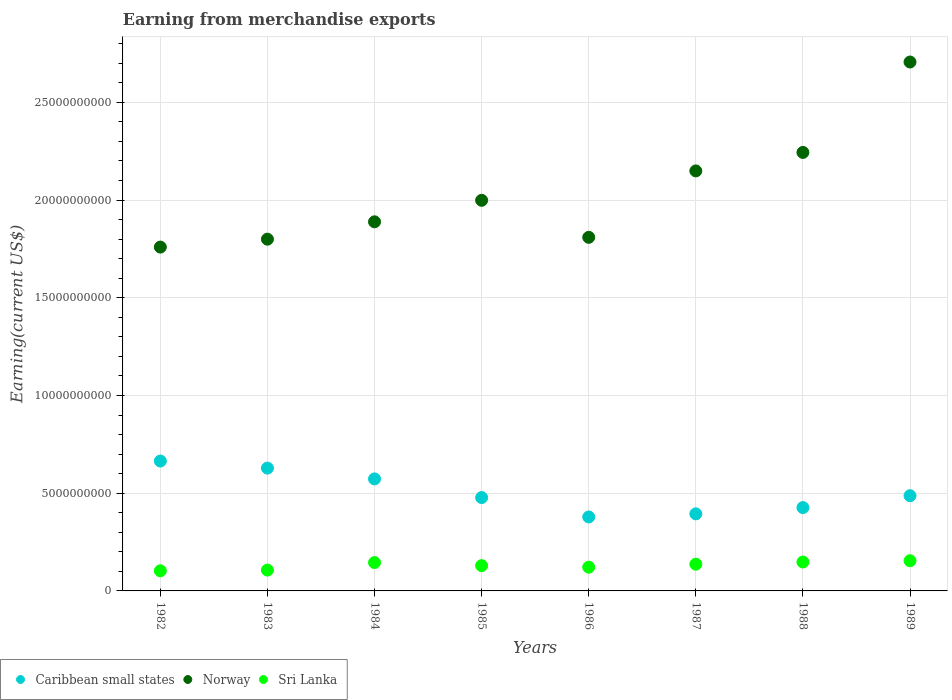Is the number of dotlines equal to the number of legend labels?
Offer a very short reply. Yes. What is the amount earned from merchandise exports in Norway in 1989?
Your response must be concise. 2.71e+1. Across all years, what is the maximum amount earned from merchandise exports in Norway?
Ensure brevity in your answer.  2.71e+1. Across all years, what is the minimum amount earned from merchandise exports in Sri Lanka?
Give a very brief answer. 1.03e+09. In which year was the amount earned from merchandise exports in Norway minimum?
Your answer should be very brief. 1982. What is the total amount earned from merchandise exports in Norway in the graph?
Give a very brief answer. 1.64e+11. What is the difference between the amount earned from merchandise exports in Sri Lanka in 1986 and that in 1989?
Keep it short and to the point. -3.30e+08. What is the difference between the amount earned from merchandise exports in Sri Lanka in 1984 and the amount earned from merchandise exports in Norway in 1982?
Provide a short and direct response. -1.61e+1. What is the average amount earned from merchandise exports in Norway per year?
Keep it short and to the point. 2.04e+1. In the year 1987, what is the difference between the amount earned from merchandise exports in Sri Lanka and amount earned from merchandise exports in Caribbean small states?
Your answer should be very brief. -2.58e+09. In how many years, is the amount earned from merchandise exports in Norway greater than 8000000000 US$?
Your response must be concise. 8. What is the ratio of the amount earned from merchandise exports in Caribbean small states in 1985 to that in 1987?
Offer a very short reply. 1.21. Is the difference between the amount earned from merchandise exports in Sri Lanka in 1986 and 1988 greater than the difference between the amount earned from merchandise exports in Caribbean small states in 1986 and 1988?
Offer a terse response. Yes. What is the difference between the highest and the second highest amount earned from merchandise exports in Norway?
Offer a terse response. 4.63e+09. What is the difference between the highest and the lowest amount earned from merchandise exports in Caribbean small states?
Offer a terse response. 2.86e+09. In how many years, is the amount earned from merchandise exports in Caribbean small states greater than the average amount earned from merchandise exports in Caribbean small states taken over all years?
Keep it short and to the point. 3. Does the amount earned from merchandise exports in Sri Lanka monotonically increase over the years?
Provide a succinct answer. No. Is the amount earned from merchandise exports in Sri Lanka strictly greater than the amount earned from merchandise exports in Norway over the years?
Keep it short and to the point. No. Is the amount earned from merchandise exports in Sri Lanka strictly less than the amount earned from merchandise exports in Norway over the years?
Your response must be concise. Yes. How many dotlines are there?
Give a very brief answer. 3. How many years are there in the graph?
Your answer should be compact. 8. Are the values on the major ticks of Y-axis written in scientific E-notation?
Ensure brevity in your answer.  No. Does the graph contain any zero values?
Offer a very short reply. No. Does the graph contain grids?
Provide a short and direct response. Yes. How are the legend labels stacked?
Make the answer very short. Horizontal. What is the title of the graph?
Offer a terse response. Earning from merchandise exports. Does "Indonesia" appear as one of the legend labels in the graph?
Your answer should be compact. No. What is the label or title of the Y-axis?
Offer a terse response. Earning(current US$). What is the Earning(current US$) of Caribbean small states in 1982?
Offer a terse response. 6.65e+09. What is the Earning(current US$) in Norway in 1982?
Your answer should be very brief. 1.76e+1. What is the Earning(current US$) in Sri Lanka in 1982?
Offer a terse response. 1.03e+09. What is the Earning(current US$) of Caribbean small states in 1983?
Offer a terse response. 6.28e+09. What is the Earning(current US$) in Norway in 1983?
Provide a succinct answer. 1.80e+1. What is the Earning(current US$) in Sri Lanka in 1983?
Offer a terse response. 1.07e+09. What is the Earning(current US$) of Caribbean small states in 1984?
Give a very brief answer. 5.73e+09. What is the Earning(current US$) in Norway in 1984?
Your answer should be very brief. 1.89e+1. What is the Earning(current US$) of Sri Lanka in 1984?
Provide a succinct answer. 1.45e+09. What is the Earning(current US$) in Caribbean small states in 1985?
Your response must be concise. 4.78e+09. What is the Earning(current US$) of Norway in 1985?
Offer a very short reply. 2.00e+1. What is the Earning(current US$) in Sri Lanka in 1985?
Keep it short and to the point. 1.29e+09. What is the Earning(current US$) in Caribbean small states in 1986?
Give a very brief answer. 3.78e+09. What is the Earning(current US$) of Norway in 1986?
Give a very brief answer. 1.81e+1. What is the Earning(current US$) in Sri Lanka in 1986?
Give a very brief answer. 1.22e+09. What is the Earning(current US$) of Caribbean small states in 1987?
Offer a very short reply. 3.94e+09. What is the Earning(current US$) in Norway in 1987?
Offer a very short reply. 2.15e+1. What is the Earning(current US$) of Sri Lanka in 1987?
Provide a succinct answer. 1.37e+09. What is the Earning(current US$) of Caribbean small states in 1988?
Provide a short and direct response. 4.26e+09. What is the Earning(current US$) of Norway in 1988?
Offer a very short reply. 2.24e+1. What is the Earning(current US$) in Sri Lanka in 1988?
Give a very brief answer. 1.48e+09. What is the Earning(current US$) of Caribbean small states in 1989?
Your response must be concise. 4.87e+09. What is the Earning(current US$) of Norway in 1989?
Offer a very short reply. 2.71e+1. What is the Earning(current US$) in Sri Lanka in 1989?
Your answer should be compact. 1.54e+09. Across all years, what is the maximum Earning(current US$) of Caribbean small states?
Give a very brief answer. 6.65e+09. Across all years, what is the maximum Earning(current US$) of Norway?
Provide a short and direct response. 2.71e+1. Across all years, what is the maximum Earning(current US$) in Sri Lanka?
Your response must be concise. 1.54e+09. Across all years, what is the minimum Earning(current US$) of Caribbean small states?
Provide a short and direct response. 3.78e+09. Across all years, what is the minimum Earning(current US$) in Norway?
Your answer should be compact. 1.76e+1. Across all years, what is the minimum Earning(current US$) of Sri Lanka?
Your answer should be very brief. 1.03e+09. What is the total Earning(current US$) of Caribbean small states in the graph?
Give a very brief answer. 4.03e+1. What is the total Earning(current US$) of Norway in the graph?
Give a very brief answer. 1.64e+11. What is the total Earning(current US$) of Sri Lanka in the graph?
Offer a very short reply. 1.04e+1. What is the difference between the Earning(current US$) in Caribbean small states in 1982 and that in 1983?
Your answer should be very brief. 3.62e+08. What is the difference between the Earning(current US$) of Norway in 1982 and that in 1983?
Offer a terse response. -4.04e+08. What is the difference between the Earning(current US$) in Sri Lanka in 1982 and that in 1983?
Your response must be concise. -3.60e+07. What is the difference between the Earning(current US$) in Caribbean small states in 1982 and that in 1984?
Offer a very short reply. 9.14e+08. What is the difference between the Earning(current US$) in Norway in 1982 and that in 1984?
Provide a short and direct response. -1.29e+09. What is the difference between the Earning(current US$) in Sri Lanka in 1982 and that in 1984?
Give a very brief answer. -4.21e+08. What is the difference between the Earning(current US$) of Caribbean small states in 1982 and that in 1985?
Your answer should be very brief. 1.87e+09. What is the difference between the Earning(current US$) of Norway in 1982 and that in 1985?
Make the answer very short. -2.39e+09. What is the difference between the Earning(current US$) in Sri Lanka in 1982 and that in 1985?
Make the answer very short. -2.63e+08. What is the difference between the Earning(current US$) of Caribbean small states in 1982 and that in 1986?
Provide a succinct answer. 2.86e+09. What is the difference between the Earning(current US$) of Norway in 1982 and that in 1986?
Your response must be concise. -4.99e+08. What is the difference between the Earning(current US$) in Sri Lanka in 1982 and that in 1986?
Keep it short and to the point. -1.85e+08. What is the difference between the Earning(current US$) of Caribbean small states in 1982 and that in 1987?
Offer a terse response. 2.70e+09. What is the difference between the Earning(current US$) of Norway in 1982 and that in 1987?
Your response must be concise. -3.90e+09. What is the difference between the Earning(current US$) of Sri Lanka in 1982 and that in 1987?
Your answer should be compact. -3.38e+08. What is the difference between the Earning(current US$) of Caribbean small states in 1982 and that in 1988?
Give a very brief answer. 2.38e+09. What is the difference between the Earning(current US$) of Norway in 1982 and that in 1988?
Provide a short and direct response. -4.84e+09. What is the difference between the Earning(current US$) in Sri Lanka in 1982 and that in 1988?
Provide a succinct answer. -4.49e+08. What is the difference between the Earning(current US$) in Caribbean small states in 1982 and that in 1989?
Ensure brevity in your answer.  1.77e+09. What is the difference between the Earning(current US$) of Norway in 1982 and that in 1989?
Make the answer very short. -9.47e+09. What is the difference between the Earning(current US$) of Sri Lanka in 1982 and that in 1989?
Keep it short and to the point. -5.15e+08. What is the difference between the Earning(current US$) in Caribbean small states in 1983 and that in 1984?
Make the answer very short. 5.52e+08. What is the difference between the Earning(current US$) in Norway in 1983 and that in 1984?
Provide a succinct answer. -8.89e+08. What is the difference between the Earning(current US$) of Sri Lanka in 1983 and that in 1984?
Your response must be concise. -3.85e+08. What is the difference between the Earning(current US$) of Caribbean small states in 1983 and that in 1985?
Offer a very short reply. 1.51e+09. What is the difference between the Earning(current US$) in Norway in 1983 and that in 1985?
Ensure brevity in your answer.  -1.99e+09. What is the difference between the Earning(current US$) in Sri Lanka in 1983 and that in 1985?
Keep it short and to the point. -2.27e+08. What is the difference between the Earning(current US$) of Caribbean small states in 1983 and that in 1986?
Your answer should be compact. 2.50e+09. What is the difference between the Earning(current US$) in Norway in 1983 and that in 1986?
Provide a succinct answer. -9.50e+07. What is the difference between the Earning(current US$) in Sri Lanka in 1983 and that in 1986?
Your answer should be compact. -1.49e+08. What is the difference between the Earning(current US$) of Caribbean small states in 1983 and that in 1987?
Provide a short and direct response. 2.34e+09. What is the difference between the Earning(current US$) in Norway in 1983 and that in 1987?
Keep it short and to the point. -3.49e+09. What is the difference between the Earning(current US$) of Sri Lanka in 1983 and that in 1987?
Provide a succinct answer. -3.02e+08. What is the difference between the Earning(current US$) of Caribbean small states in 1983 and that in 1988?
Your answer should be compact. 2.02e+09. What is the difference between the Earning(current US$) in Norway in 1983 and that in 1988?
Offer a terse response. -4.44e+09. What is the difference between the Earning(current US$) of Sri Lanka in 1983 and that in 1988?
Provide a short and direct response. -4.13e+08. What is the difference between the Earning(current US$) in Caribbean small states in 1983 and that in 1989?
Give a very brief answer. 1.41e+09. What is the difference between the Earning(current US$) in Norway in 1983 and that in 1989?
Your answer should be compact. -9.06e+09. What is the difference between the Earning(current US$) of Sri Lanka in 1983 and that in 1989?
Give a very brief answer. -4.79e+08. What is the difference between the Earning(current US$) of Caribbean small states in 1984 and that in 1985?
Provide a short and direct response. 9.55e+08. What is the difference between the Earning(current US$) of Norway in 1984 and that in 1985?
Give a very brief answer. -1.10e+09. What is the difference between the Earning(current US$) in Sri Lanka in 1984 and that in 1985?
Your answer should be compact. 1.58e+08. What is the difference between the Earning(current US$) in Caribbean small states in 1984 and that in 1986?
Your answer should be very brief. 1.95e+09. What is the difference between the Earning(current US$) of Norway in 1984 and that in 1986?
Ensure brevity in your answer.  7.94e+08. What is the difference between the Earning(current US$) in Sri Lanka in 1984 and that in 1986?
Ensure brevity in your answer.  2.36e+08. What is the difference between the Earning(current US$) of Caribbean small states in 1984 and that in 1987?
Provide a succinct answer. 1.79e+09. What is the difference between the Earning(current US$) in Norway in 1984 and that in 1987?
Your answer should be very brief. -2.60e+09. What is the difference between the Earning(current US$) of Sri Lanka in 1984 and that in 1987?
Keep it short and to the point. 8.30e+07. What is the difference between the Earning(current US$) of Caribbean small states in 1984 and that in 1988?
Your answer should be compact. 1.47e+09. What is the difference between the Earning(current US$) of Norway in 1984 and that in 1988?
Your answer should be very brief. -3.55e+09. What is the difference between the Earning(current US$) in Sri Lanka in 1984 and that in 1988?
Offer a very short reply. -2.80e+07. What is the difference between the Earning(current US$) in Caribbean small states in 1984 and that in 1989?
Give a very brief answer. 8.60e+08. What is the difference between the Earning(current US$) of Norway in 1984 and that in 1989?
Your answer should be very brief. -8.18e+09. What is the difference between the Earning(current US$) in Sri Lanka in 1984 and that in 1989?
Make the answer very short. -9.40e+07. What is the difference between the Earning(current US$) in Caribbean small states in 1985 and that in 1986?
Your answer should be compact. 9.92e+08. What is the difference between the Earning(current US$) of Norway in 1985 and that in 1986?
Your response must be concise. 1.89e+09. What is the difference between the Earning(current US$) in Sri Lanka in 1985 and that in 1986?
Make the answer very short. 7.80e+07. What is the difference between the Earning(current US$) in Caribbean small states in 1985 and that in 1987?
Give a very brief answer. 8.34e+08. What is the difference between the Earning(current US$) of Norway in 1985 and that in 1987?
Offer a very short reply. -1.50e+09. What is the difference between the Earning(current US$) in Sri Lanka in 1985 and that in 1987?
Your answer should be compact. -7.50e+07. What is the difference between the Earning(current US$) in Caribbean small states in 1985 and that in 1988?
Make the answer very short. 5.13e+08. What is the difference between the Earning(current US$) in Norway in 1985 and that in 1988?
Offer a terse response. -2.45e+09. What is the difference between the Earning(current US$) in Sri Lanka in 1985 and that in 1988?
Offer a very short reply. -1.86e+08. What is the difference between the Earning(current US$) in Caribbean small states in 1985 and that in 1989?
Ensure brevity in your answer.  -9.50e+07. What is the difference between the Earning(current US$) in Norway in 1985 and that in 1989?
Keep it short and to the point. -7.08e+09. What is the difference between the Earning(current US$) of Sri Lanka in 1985 and that in 1989?
Keep it short and to the point. -2.52e+08. What is the difference between the Earning(current US$) in Caribbean small states in 1986 and that in 1987?
Offer a very short reply. -1.58e+08. What is the difference between the Earning(current US$) in Norway in 1986 and that in 1987?
Keep it short and to the point. -3.40e+09. What is the difference between the Earning(current US$) in Sri Lanka in 1986 and that in 1987?
Give a very brief answer. -1.53e+08. What is the difference between the Earning(current US$) of Caribbean small states in 1986 and that in 1988?
Give a very brief answer. -4.79e+08. What is the difference between the Earning(current US$) in Norway in 1986 and that in 1988?
Give a very brief answer. -4.34e+09. What is the difference between the Earning(current US$) of Sri Lanka in 1986 and that in 1988?
Make the answer very short. -2.64e+08. What is the difference between the Earning(current US$) of Caribbean small states in 1986 and that in 1989?
Ensure brevity in your answer.  -1.09e+09. What is the difference between the Earning(current US$) of Norway in 1986 and that in 1989?
Provide a succinct answer. -8.97e+09. What is the difference between the Earning(current US$) in Sri Lanka in 1986 and that in 1989?
Your response must be concise. -3.30e+08. What is the difference between the Earning(current US$) in Caribbean small states in 1987 and that in 1988?
Offer a very short reply. -3.21e+08. What is the difference between the Earning(current US$) of Norway in 1987 and that in 1988?
Keep it short and to the point. -9.46e+08. What is the difference between the Earning(current US$) in Sri Lanka in 1987 and that in 1988?
Your response must be concise. -1.11e+08. What is the difference between the Earning(current US$) of Caribbean small states in 1987 and that in 1989?
Your response must be concise. -9.29e+08. What is the difference between the Earning(current US$) of Norway in 1987 and that in 1989?
Ensure brevity in your answer.  -5.57e+09. What is the difference between the Earning(current US$) in Sri Lanka in 1987 and that in 1989?
Make the answer very short. -1.77e+08. What is the difference between the Earning(current US$) in Caribbean small states in 1988 and that in 1989?
Your answer should be very brief. -6.08e+08. What is the difference between the Earning(current US$) in Norway in 1988 and that in 1989?
Offer a terse response. -4.63e+09. What is the difference between the Earning(current US$) in Sri Lanka in 1988 and that in 1989?
Provide a short and direct response. -6.60e+07. What is the difference between the Earning(current US$) in Caribbean small states in 1982 and the Earning(current US$) in Norway in 1983?
Ensure brevity in your answer.  -1.14e+1. What is the difference between the Earning(current US$) in Caribbean small states in 1982 and the Earning(current US$) in Sri Lanka in 1983?
Your response must be concise. 5.58e+09. What is the difference between the Earning(current US$) of Norway in 1982 and the Earning(current US$) of Sri Lanka in 1983?
Ensure brevity in your answer.  1.65e+1. What is the difference between the Earning(current US$) in Caribbean small states in 1982 and the Earning(current US$) in Norway in 1984?
Keep it short and to the point. -1.22e+1. What is the difference between the Earning(current US$) of Caribbean small states in 1982 and the Earning(current US$) of Sri Lanka in 1984?
Give a very brief answer. 5.20e+09. What is the difference between the Earning(current US$) in Norway in 1982 and the Earning(current US$) in Sri Lanka in 1984?
Provide a short and direct response. 1.61e+1. What is the difference between the Earning(current US$) of Caribbean small states in 1982 and the Earning(current US$) of Norway in 1985?
Keep it short and to the point. -1.33e+1. What is the difference between the Earning(current US$) of Caribbean small states in 1982 and the Earning(current US$) of Sri Lanka in 1985?
Give a very brief answer. 5.35e+09. What is the difference between the Earning(current US$) of Norway in 1982 and the Earning(current US$) of Sri Lanka in 1985?
Your answer should be very brief. 1.63e+1. What is the difference between the Earning(current US$) of Caribbean small states in 1982 and the Earning(current US$) of Norway in 1986?
Your answer should be compact. -1.14e+1. What is the difference between the Earning(current US$) of Caribbean small states in 1982 and the Earning(current US$) of Sri Lanka in 1986?
Ensure brevity in your answer.  5.43e+09. What is the difference between the Earning(current US$) in Norway in 1982 and the Earning(current US$) in Sri Lanka in 1986?
Give a very brief answer. 1.64e+1. What is the difference between the Earning(current US$) in Caribbean small states in 1982 and the Earning(current US$) in Norway in 1987?
Your response must be concise. -1.48e+1. What is the difference between the Earning(current US$) of Caribbean small states in 1982 and the Earning(current US$) of Sri Lanka in 1987?
Your response must be concise. 5.28e+09. What is the difference between the Earning(current US$) in Norway in 1982 and the Earning(current US$) in Sri Lanka in 1987?
Give a very brief answer. 1.62e+1. What is the difference between the Earning(current US$) of Caribbean small states in 1982 and the Earning(current US$) of Norway in 1988?
Make the answer very short. -1.58e+1. What is the difference between the Earning(current US$) in Caribbean small states in 1982 and the Earning(current US$) in Sri Lanka in 1988?
Offer a terse response. 5.17e+09. What is the difference between the Earning(current US$) in Norway in 1982 and the Earning(current US$) in Sri Lanka in 1988?
Keep it short and to the point. 1.61e+1. What is the difference between the Earning(current US$) in Caribbean small states in 1982 and the Earning(current US$) in Norway in 1989?
Your response must be concise. -2.04e+1. What is the difference between the Earning(current US$) in Caribbean small states in 1982 and the Earning(current US$) in Sri Lanka in 1989?
Your answer should be compact. 5.10e+09. What is the difference between the Earning(current US$) in Norway in 1982 and the Earning(current US$) in Sri Lanka in 1989?
Offer a very short reply. 1.60e+1. What is the difference between the Earning(current US$) of Caribbean small states in 1983 and the Earning(current US$) of Norway in 1984?
Offer a very short reply. -1.26e+1. What is the difference between the Earning(current US$) in Caribbean small states in 1983 and the Earning(current US$) in Sri Lanka in 1984?
Provide a succinct answer. 4.83e+09. What is the difference between the Earning(current US$) of Norway in 1983 and the Earning(current US$) of Sri Lanka in 1984?
Provide a short and direct response. 1.65e+1. What is the difference between the Earning(current US$) in Caribbean small states in 1983 and the Earning(current US$) in Norway in 1985?
Offer a terse response. -1.37e+1. What is the difference between the Earning(current US$) in Caribbean small states in 1983 and the Earning(current US$) in Sri Lanka in 1985?
Offer a terse response. 4.99e+09. What is the difference between the Earning(current US$) of Norway in 1983 and the Earning(current US$) of Sri Lanka in 1985?
Your answer should be compact. 1.67e+1. What is the difference between the Earning(current US$) of Caribbean small states in 1983 and the Earning(current US$) of Norway in 1986?
Keep it short and to the point. -1.18e+1. What is the difference between the Earning(current US$) in Caribbean small states in 1983 and the Earning(current US$) in Sri Lanka in 1986?
Provide a short and direct response. 5.07e+09. What is the difference between the Earning(current US$) of Norway in 1983 and the Earning(current US$) of Sri Lanka in 1986?
Give a very brief answer. 1.68e+1. What is the difference between the Earning(current US$) of Caribbean small states in 1983 and the Earning(current US$) of Norway in 1987?
Give a very brief answer. -1.52e+1. What is the difference between the Earning(current US$) of Caribbean small states in 1983 and the Earning(current US$) of Sri Lanka in 1987?
Your response must be concise. 4.92e+09. What is the difference between the Earning(current US$) in Norway in 1983 and the Earning(current US$) in Sri Lanka in 1987?
Your answer should be very brief. 1.66e+1. What is the difference between the Earning(current US$) of Caribbean small states in 1983 and the Earning(current US$) of Norway in 1988?
Keep it short and to the point. -1.62e+1. What is the difference between the Earning(current US$) in Caribbean small states in 1983 and the Earning(current US$) in Sri Lanka in 1988?
Provide a succinct answer. 4.80e+09. What is the difference between the Earning(current US$) in Norway in 1983 and the Earning(current US$) in Sri Lanka in 1988?
Your answer should be compact. 1.65e+1. What is the difference between the Earning(current US$) in Caribbean small states in 1983 and the Earning(current US$) in Norway in 1989?
Give a very brief answer. -2.08e+1. What is the difference between the Earning(current US$) in Caribbean small states in 1983 and the Earning(current US$) in Sri Lanka in 1989?
Offer a terse response. 4.74e+09. What is the difference between the Earning(current US$) of Norway in 1983 and the Earning(current US$) of Sri Lanka in 1989?
Provide a short and direct response. 1.65e+1. What is the difference between the Earning(current US$) of Caribbean small states in 1984 and the Earning(current US$) of Norway in 1985?
Offer a very short reply. -1.43e+1. What is the difference between the Earning(current US$) of Caribbean small states in 1984 and the Earning(current US$) of Sri Lanka in 1985?
Keep it short and to the point. 4.44e+09. What is the difference between the Earning(current US$) in Norway in 1984 and the Earning(current US$) in Sri Lanka in 1985?
Offer a very short reply. 1.76e+1. What is the difference between the Earning(current US$) in Caribbean small states in 1984 and the Earning(current US$) in Norway in 1986?
Offer a terse response. -1.24e+1. What is the difference between the Earning(current US$) in Caribbean small states in 1984 and the Earning(current US$) in Sri Lanka in 1986?
Offer a terse response. 4.52e+09. What is the difference between the Earning(current US$) of Norway in 1984 and the Earning(current US$) of Sri Lanka in 1986?
Make the answer very short. 1.77e+1. What is the difference between the Earning(current US$) in Caribbean small states in 1984 and the Earning(current US$) in Norway in 1987?
Ensure brevity in your answer.  -1.58e+1. What is the difference between the Earning(current US$) of Caribbean small states in 1984 and the Earning(current US$) of Sri Lanka in 1987?
Your answer should be compact. 4.36e+09. What is the difference between the Earning(current US$) in Norway in 1984 and the Earning(current US$) in Sri Lanka in 1987?
Your answer should be compact. 1.75e+1. What is the difference between the Earning(current US$) in Caribbean small states in 1984 and the Earning(current US$) in Norway in 1988?
Keep it short and to the point. -1.67e+1. What is the difference between the Earning(current US$) in Caribbean small states in 1984 and the Earning(current US$) in Sri Lanka in 1988?
Provide a short and direct response. 4.25e+09. What is the difference between the Earning(current US$) in Norway in 1984 and the Earning(current US$) in Sri Lanka in 1988?
Provide a succinct answer. 1.74e+1. What is the difference between the Earning(current US$) in Caribbean small states in 1984 and the Earning(current US$) in Norway in 1989?
Offer a very short reply. -2.13e+1. What is the difference between the Earning(current US$) in Caribbean small states in 1984 and the Earning(current US$) in Sri Lanka in 1989?
Give a very brief answer. 4.19e+09. What is the difference between the Earning(current US$) in Norway in 1984 and the Earning(current US$) in Sri Lanka in 1989?
Offer a very short reply. 1.73e+1. What is the difference between the Earning(current US$) of Caribbean small states in 1985 and the Earning(current US$) of Norway in 1986?
Your answer should be very brief. -1.33e+1. What is the difference between the Earning(current US$) in Caribbean small states in 1985 and the Earning(current US$) in Sri Lanka in 1986?
Provide a succinct answer. 3.56e+09. What is the difference between the Earning(current US$) of Norway in 1985 and the Earning(current US$) of Sri Lanka in 1986?
Provide a succinct answer. 1.88e+1. What is the difference between the Earning(current US$) of Caribbean small states in 1985 and the Earning(current US$) of Norway in 1987?
Your response must be concise. -1.67e+1. What is the difference between the Earning(current US$) in Caribbean small states in 1985 and the Earning(current US$) in Sri Lanka in 1987?
Your answer should be compact. 3.41e+09. What is the difference between the Earning(current US$) of Norway in 1985 and the Earning(current US$) of Sri Lanka in 1987?
Give a very brief answer. 1.86e+1. What is the difference between the Earning(current US$) of Caribbean small states in 1985 and the Earning(current US$) of Norway in 1988?
Make the answer very short. -1.77e+1. What is the difference between the Earning(current US$) in Caribbean small states in 1985 and the Earning(current US$) in Sri Lanka in 1988?
Offer a very short reply. 3.30e+09. What is the difference between the Earning(current US$) in Norway in 1985 and the Earning(current US$) in Sri Lanka in 1988?
Your answer should be very brief. 1.85e+1. What is the difference between the Earning(current US$) of Caribbean small states in 1985 and the Earning(current US$) of Norway in 1989?
Your answer should be very brief. -2.23e+1. What is the difference between the Earning(current US$) of Caribbean small states in 1985 and the Earning(current US$) of Sri Lanka in 1989?
Your answer should be very brief. 3.23e+09. What is the difference between the Earning(current US$) of Norway in 1985 and the Earning(current US$) of Sri Lanka in 1989?
Keep it short and to the point. 1.84e+1. What is the difference between the Earning(current US$) of Caribbean small states in 1986 and the Earning(current US$) of Norway in 1987?
Offer a very short reply. -1.77e+1. What is the difference between the Earning(current US$) of Caribbean small states in 1986 and the Earning(current US$) of Sri Lanka in 1987?
Your answer should be compact. 2.42e+09. What is the difference between the Earning(current US$) in Norway in 1986 and the Earning(current US$) in Sri Lanka in 1987?
Make the answer very short. 1.67e+1. What is the difference between the Earning(current US$) of Caribbean small states in 1986 and the Earning(current US$) of Norway in 1988?
Provide a short and direct response. -1.87e+1. What is the difference between the Earning(current US$) of Caribbean small states in 1986 and the Earning(current US$) of Sri Lanka in 1988?
Your answer should be compact. 2.31e+09. What is the difference between the Earning(current US$) in Norway in 1986 and the Earning(current US$) in Sri Lanka in 1988?
Ensure brevity in your answer.  1.66e+1. What is the difference between the Earning(current US$) in Caribbean small states in 1986 and the Earning(current US$) in Norway in 1989?
Provide a succinct answer. -2.33e+1. What is the difference between the Earning(current US$) of Caribbean small states in 1986 and the Earning(current US$) of Sri Lanka in 1989?
Your response must be concise. 2.24e+09. What is the difference between the Earning(current US$) of Norway in 1986 and the Earning(current US$) of Sri Lanka in 1989?
Make the answer very short. 1.65e+1. What is the difference between the Earning(current US$) in Caribbean small states in 1987 and the Earning(current US$) in Norway in 1988?
Your answer should be very brief. -1.85e+1. What is the difference between the Earning(current US$) of Caribbean small states in 1987 and the Earning(current US$) of Sri Lanka in 1988?
Give a very brief answer. 2.46e+09. What is the difference between the Earning(current US$) of Norway in 1987 and the Earning(current US$) of Sri Lanka in 1988?
Ensure brevity in your answer.  2.00e+1. What is the difference between the Earning(current US$) of Caribbean small states in 1987 and the Earning(current US$) of Norway in 1989?
Keep it short and to the point. -2.31e+1. What is the difference between the Earning(current US$) of Caribbean small states in 1987 and the Earning(current US$) of Sri Lanka in 1989?
Your answer should be very brief. 2.40e+09. What is the difference between the Earning(current US$) in Norway in 1987 and the Earning(current US$) in Sri Lanka in 1989?
Your answer should be compact. 1.99e+1. What is the difference between the Earning(current US$) in Caribbean small states in 1988 and the Earning(current US$) in Norway in 1989?
Your answer should be very brief. -2.28e+1. What is the difference between the Earning(current US$) of Caribbean small states in 1988 and the Earning(current US$) of Sri Lanka in 1989?
Offer a terse response. 2.72e+09. What is the difference between the Earning(current US$) in Norway in 1988 and the Earning(current US$) in Sri Lanka in 1989?
Offer a very short reply. 2.09e+1. What is the average Earning(current US$) in Caribbean small states per year?
Offer a very short reply. 5.04e+09. What is the average Earning(current US$) in Norway per year?
Your answer should be compact. 2.04e+1. What is the average Earning(current US$) in Sri Lanka per year?
Your answer should be compact. 1.31e+09. In the year 1982, what is the difference between the Earning(current US$) of Caribbean small states and Earning(current US$) of Norway?
Your answer should be compact. -1.09e+1. In the year 1982, what is the difference between the Earning(current US$) of Caribbean small states and Earning(current US$) of Sri Lanka?
Provide a succinct answer. 5.62e+09. In the year 1982, what is the difference between the Earning(current US$) of Norway and Earning(current US$) of Sri Lanka?
Offer a terse response. 1.66e+1. In the year 1983, what is the difference between the Earning(current US$) in Caribbean small states and Earning(current US$) in Norway?
Your answer should be compact. -1.17e+1. In the year 1983, what is the difference between the Earning(current US$) of Caribbean small states and Earning(current US$) of Sri Lanka?
Ensure brevity in your answer.  5.22e+09. In the year 1983, what is the difference between the Earning(current US$) in Norway and Earning(current US$) in Sri Lanka?
Ensure brevity in your answer.  1.69e+1. In the year 1984, what is the difference between the Earning(current US$) in Caribbean small states and Earning(current US$) in Norway?
Provide a short and direct response. -1.32e+1. In the year 1984, what is the difference between the Earning(current US$) in Caribbean small states and Earning(current US$) in Sri Lanka?
Make the answer very short. 4.28e+09. In the year 1984, what is the difference between the Earning(current US$) in Norway and Earning(current US$) in Sri Lanka?
Offer a terse response. 1.74e+1. In the year 1985, what is the difference between the Earning(current US$) of Caribbean small states and Earning(current US$) of Norway?
Keep it short and to the point. -1.52e+1. In the year 1985, what is the difference between the Earning(current US$) in Caribbean small states and Earning(current US$) in Sri Lanka?
Your answer should be very brief. 3.48e+09. In the year 1985, what is the difference between the Earning(current US$) in Norway and Earning(current US$) in Sri Lanka?
Provide a short and direct response. 1.87e+1. In the year 1986, what is the difference between the Earning(current US$) in Caribbean small states and Earning(current US$) in Norway?
Your answer should be compact. -1.43e+1. In the year 1986, what is the difference between the Earning(current US$) in Caribbean small states and Earning(current US$) in Sri Lanka?
Your answer should be compact. 2.57e+09. In the year 1986, what is the difference between the Earning(current US$) in Norway and Earning(current US$) in Sri Lanka?
Your answer should be compact. 1.69e+1. In the year 1987, what is the difference between the Earning(current US$) of Caribbean small states and Earning(current US$) of Norway?
Your response must be concise. -1.75e+1. In the year 1987, what is the difference between the Earning(current US$) in Caribbean small states and Earning(current US$) in Sri Lanka?
Your response must be concise. 2.58e+09. In the year 1987, what is the difference between the Earning(current US$) of Norway and Earning(current US$) of Sri Lanka?
Provide a short and direct response. 2.01e+1. In the year 1988, what is the difference between the Earning(current US$) of Caribbean small states and Earning(current US$) of Norway?
Your answer should be very brief. -1.82e+1. In the year 1988, what is the difference between the Earning(current US$) in Caribbean small states and Earning(current US$) in Sri Lanka?
Your answer should be compact. 2.78e+09. In the year 1988, what is the difference between the Earning(current US$) of Norway and Earning(current US$) of Sri Lanka?
Ensure brevity in your answer.  2.10e+1. In the year 1989, what is the difference between the Earning(current US$) in Caribbean small states and Earning(current US$) in Norway?
Provide a succinct answer. -2.22e+1. In the year 1989, what is the difference between the Earning(current US$) in Caribbean small states and Earning(current US$) in Sri Lanka?
Keep it short and to the point. 3.33e+09. In the year 1989, what is the difference between the Earning(current US$) of Norway and Earning(current US$) of Sri Lanka?
Your answer should be compact. 2.55e+1. What is the ratio of the Earning(current US$) in Caribbean small states in 1982 to that in 1983?
Give a very brief answer. 1.06. What is the ratio of the Earning(current US$) in Norway in 1982 to that in 1983?
Provide a succinct answer. 0.98. What is the ratio of the Earning(current US$) in Sri Lanka in 1982 to that in 1983?
Your response must be concise. 0.97. What is the ratio of the Earning(current US$) in Caribbean small states in 1982 to that in 1984?
Offer a terse response. 1.16. What is the ratio of the Earning(current US$) of Norway in 1982 to that in 1984?
Offer a terse response. 0.93. What is the ratio of the Earning(current US$) in Sri Lanka in 1982 to that in 1984?
Your answer should be compact. 0.71. What is the ratio of the Earning(current US$) of Caribbean small states in 1982 to that in 1985?
Your answer should be compact. 1.39. What is the ratio of the Earning(current US$) in Norway in 1982 to that in 1985?
Offer a very short reply. 0.88. What is the ratio of the Earning(current US$) in Sri Lanka in 1982 to that in 1985?
Make the answer very short. 0.8. What is the ratio of the Earning(current US$) in Caribbean small states in 1982 to that in 1986?
Offer a terse response. 1.76. What is the ratio of the Earning(current US$) of Norway in 1982 to that in 1986?
Give a very brief answer. 0.97. What is the ratio of the Earning(current US$) in Sri Lanka in 1982 to that in 1986?
Make the answer very short. 0.85. What is the ratio of the Earning(current US$) in Caribbean small states in 1982 to that in 1987?
Your answer should be compact. 1.69. What is the ratio of the Earning(current US$) of Norway in 1982 to that in 1987?
Your response must be concise. 0.82. What is the ratio of the Earning(current US$) in Sri Lanka in 1982 to that in 1987?
Your response must be concise. 0.75. What is the ratio of the Earning(current US$) in Caribbean small states in 1982 to that in 1988?
Your response must be concise. 1.56. What is the ratio of the Earning(current US$) of Norway in 1982 to that in 1988?
Provide a short and direct response. 0.78. What is the ratio of the Earning(current US$) in Sri Lanka in 1982 to that in 1988?
Your answer should be very brief. 0.7. What is the ratio of the Earning(current US$) in Caribbean small states in 1982 to that in 1989?
Ensure brevity in your answer.  1.36. What is the ratio of the Earning(current US$) in Norway in 1982 to that in 1989?
Your answer should be very brief. 0.65. What is the ratio of the Earning(current US$) of Caribbean small states in 1983 to that in 1984?
Keep it short and to the point. 1.1. What is the ratio of the Earning(current US$) in Norway in 1983 to that in 1984?
Your answer should be compact. 0.95. What is the ratio of the Earning(current US$) of Sri Lanka in 1983 to that in 1984?
Ensure brevity in your answer.  0.73. What is the ratio of the Earning(current US$) of Caribbean small states in 1983 to that in 1985?
Offer a terse response. 1.32. What is the ratio of the Earning(current US$) of Norway in 1983 to that in 1985?
Make the answer very short. 0.9. What is the ratio of the Earning(current US$) of Sri Lanka in 1983 to that in 1985?
Keep it short and to the point. 0.82. What is the ratio of the Earning(current US$) in Caribbean small states in 1983 to that in 1986?
Provide a succinct answer. 1.66. What is the ratio of the Earning(current US$) of Norway in 1983 to that in 1986?
Offer a very short reply. 0.99. What is the ratio of the Earning(current US$) of Sri Lanka in 1983 to that in 1986?
Ensure brevity in your answer.  0.88. What is the ratio of the Earning(current US$) of Caribbean small states in 1983 to that in 1987?
Make the answer very short. 1.59. What is the ratio of the Earning(current US$) of Norway in 1983 to that in 1987?
Make the answer very short. 0.84. What is the ratio of the Earning(current US$) in Sri Lanka in 1983 to that in 1987?
Offer a terse response. 0.78. What is the ratio of the Earning(current US$) of Caribbean small states in 1983 to that in 1988?
Your response must be concise. 1.47. What is the ratio of the Earning(current US$) of Norway in 1983 to that in 1988?
Give a very brief answer. 0.8. What is the ratio of the Earning(current US$) in Sri Lanka in 1983 to that in 1988?
Give a very brief answer. 0.72. What is the ratio of the Earning(current US$) of Caribbean small states in 1983 to that in 1989?
Keep it short and to the point. 1.29. What is the ratio of the Earning(current US$) in Norway in 1983 to that in 1989?
Offer a very short reply. 0.67. What is the ratio of the Earning(current US$) in Sri Lanka in 1983 to that in 1989?
Your response must be concise. 0.69. What is the ratio of the Earning(current US$) in Caribbean small states in 1984 to that in 1985?
Keep it short and to the point. 1.2. What is the ratio of the Earning(current US$) of Norway in 1984 to that in 1985?
Provide a short and direct response. 0.94. What is the ratio of the Earning(current US$) of Sri Lanka in 1984 to that in 1985?
Offer a very short reply. 1.12. What is the ratio of the Earning(current US$) of Caribbean small states in 1984 to that in 1986?
Ensure brevity in your answer.  1.51. What is the ratio of the Earning(current US$) in Norway in 1984 to that in 1986?
Offer a very short reply. 1.04. What is the ratio of the Earning(current US$) of Sri Lanka in 1984 to that in 1986?
Keep it short and to the point. 1.19. What is the ratio of the Earning(current US$) in Caribbean small states in 1984 to that in 1987?
Offer a terse response. 1.45. What is the ratio of the Earning(current US$) in Norway in 1984 to that in 1987?
Your answer should be very brief. 0.88. What is the ratio of the Earning(current US$) of Sri Lanka in 1984 to that in 1987?
Keep it short and to the point. 1.06. What is the ratio of the Earning(current US$) of Caribbean small states in 1984 to that in 1988?
Offer a very short reply. 1.34. What is the ratio of the Earning(current US$) of Norway in 1984 to that in 1988?
Offer a very short reply. 0.84. What is the ratio of the Earning(current US$) of Sri Lanka in 1984 to that in 1988?
Provide a short and direct response. 0.98. What is the ratio of the Earning(current US$) in Caribbean small states in 1984 to that in 1989?
Ensure brevity in your answer.  1.18. What is the ratio of the Earning(current US$) of Norway in 1984 to that in 1989?
Your answer should be very brief. 0.7. What is the ratio of the Earning(current US$) in Sri Lanka in 1984 to that in 1989?
Your answer should be compact. 0.94. What is the ratio of the Earning(current US$) of Caribbean small states in 1985 to that in 1986?
Your answer should be very brief. 1.26. What is the ratio of the Earning(current US$) in Norway in 1985 to that in 1986?
Offer a terse response. 1.1. What is the ratio of the Earning(current US$) of Sri Lanka in 1985 to that in 1986?
Ensure brevity in your answer.  1.06. What is the ratio of the Earning(current US$) in Caribbean small states in 1985 to that in 1987?
Ensure brevity in your answer.  1.21. What is the ratio of the Earning(current US$) in Norway in 1985 to that in 1987?
Keep it short and to the point. 0.93. What is the ratio of the Earning(current US$) in Sri Lanka in 1985 to that in 1987?
Ensure brevity in your answer.  0.95. What is the ratio of the Earning(current US$) of Caribbean small states in 1985 to that in 1988?
Your response must be concise. 1.12. What is the ratio of the Earning(current US$) in Norway in 1985 to that in 1988?
Give a very brief answer. 0.89. What is the ratio of the Earning(current US$) in Sri Lanka in 1985 to that in 1988?
Make the answer very short. 0.87. What is the ratio of the Earning(current US$) of Caribbean small states in 1985 to that in 1989?
Ensure brevity in your answer.  0.98. What is the ratio of the Earning(current US$) in Norway in 1985 to that in 1989?
Keep it short and to the point. 0.74. What is the ratio of the Earning(current US$) of Sri Lanka in 1985 to that in 1989?
Your answer should be very brief. 0.84. What is the ratio of the Earning(current US$) in Caribbean small states in 1986 to that in 1987?
Your response must be concise. 0.96. What is the ratio of the Earning(current US$) of Norway in 1986 to that in 1987?
Ensure brevity in your answer.  0.84. What is the ratio of the Earning(current US$) in Sri Lanka in 1986 to that in 1987?
Your response must be concise. 0.89. What is the ratio of the Earning(current US$) of Caribbean small states in 1986 to that in 1988?
Provide a short and direct response. 0.89. What is the ratio of the Earning(current US$) of Norway in 1986 to that in 1988?
Your answer should be compact. 0.81. What is the ratio of the Earning(current US$) of Sri Lanka in 1986 to that in 1988?
Your response must be concise. 0.82. What is the ratio of the Earning(current US$) of Caribbean small states in 1986 to that in 1989?
Ensure brevity in your answer.  0.78. What is the ratio of the Earning(current US$) in Norway in 1986 to that in 1989?
Give a very brief answer. 0.67. What is the ratio of the Earning(current US$) in Sri Lanka in 1986 to that in 1989?
Your answer should be compact. 0.79. What is the ratio of the Earning(current US$) of Caribbean small states in 1987 to that in 1988?
Give a very brief answer. 0.92. What is the ratio of the Earning(current US$) in Norway in 1987 to that in 1988?
Make the answer very short. 0.96. What is the ratio of the Earning(current US$) of Sri Lanka in 1987 to that in 1988?
Make the answer very short. 0.92. What is the ratio of the Earning(current US$) of Caribbean small states in 1987 to that in 1989?
Give a very brief answer. 0.81. What is the ratio of the Earning(current US$) of Norway in 1987 to that in 1989?
Provide a short and direct response. 0.79. What is the ratio of the Earning(current US$) of Sri Lanka in 1987 to that in 1989?
Offer a very short reply. 0.89. What is the ratio of the Earning(current US$) in Caribbean small states in 1988 to that in 1989?
Offer a terse response. 0.88. What is the ratio of the Earning(current US$) in Norway in 1988 to that in 1989?
Provide a short and direct response. 0.83. What is the ratio of the Earning(current US$) of Sri Lanka in 1988 to that in 1989?
Provide a short and direct response. 0.96. What is the difference between the highest and the second highest Earning(current US$) of Caribbean small states?
Give a very brief answer. 3.62e+08. What is the difference between the highest and the second highest Earning(current US$) of Norway?
Offer a very short reply. 4.63e+09. What is the difference between the highest and the second highest Earning(current US$) of Sri Lanka?
Offer a very short reply. 6.60e+07. What is the difference between the highest and the lowest Earning(current US$) in Caribbean small states?
Provide a succinct answer. 2.86e+09. What is the difference between the highest and the lowest Earning(current US$) of Norway?
Keep it short and to the point. 9.47e+09. What is the difference between the highest and the lowest Earning(current US$) of Sri Lanka?
Your answer should be very brief. 5.15e+08. 